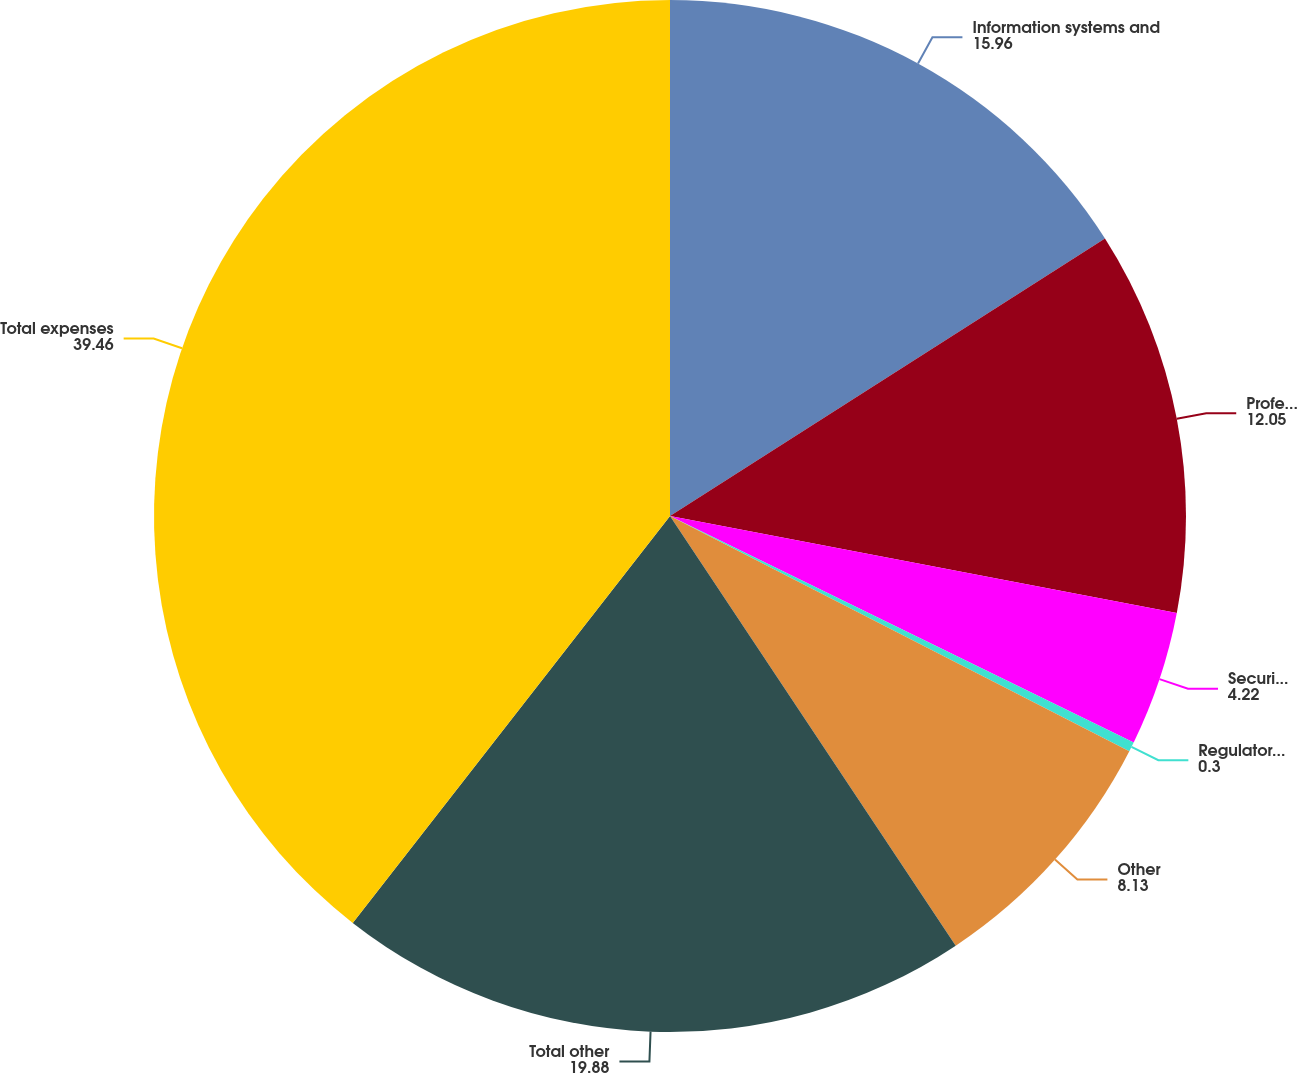Convert chart to OTSL. <chart><loc_0><loc_0><loc_500><loc_500><pie_chart><fcel>Information systems and<fcel>Professional services<fcel>Securities processing costs<fcel>Regulator fees and assessments<fcel>Other<fcel>Total other<fcel>Total expenses<nl><fcel>15.96%<fcel>12.05%<fcel>4.22%<fcel>0.3%<fcel>8.13%<fcel>19.88%<fcel>39.46%<nl></chart> 